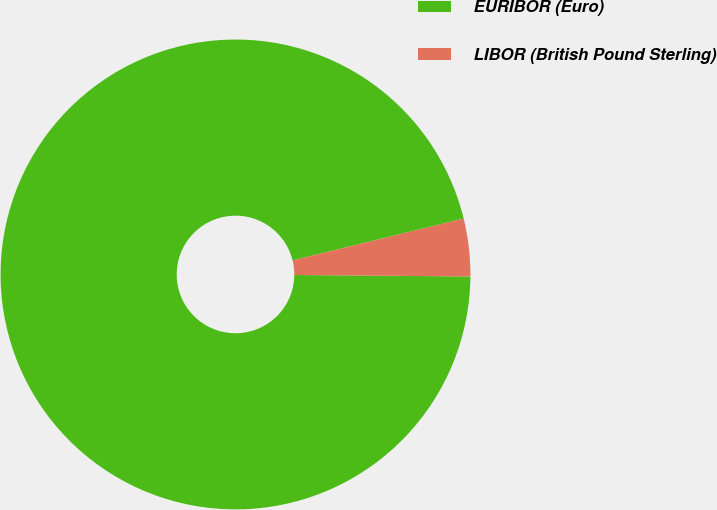<chart> <loc_0><loc_0><loc_500><loc_500><pie_chart><fcel>EURIBOR (Euro)<fcel>LIBOR (British Pound Sterling)<nl><fcel>96.04%<fcel>3.96%<nl></chart> 